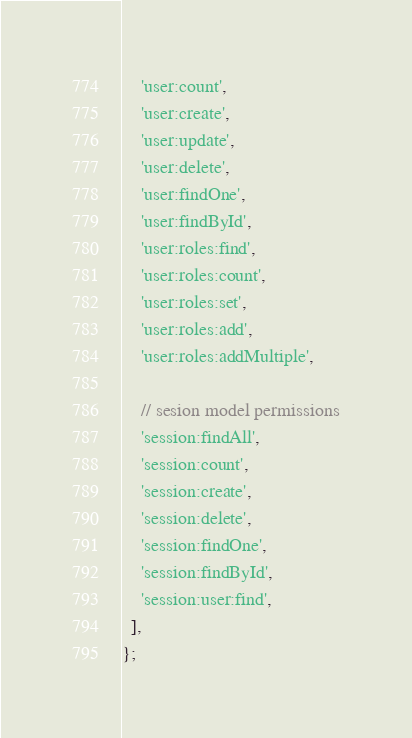<code> <loc_0><loc_0><loc_500><loc_500><_JavaScript_>    'user:count',
    'user:create',
    'user:update',
    'user:delete',
    'user:findOne',
    'user:findById',
    'user:roles:find',
    'user:roles:count',
    'user:roles:set',
    'user:roles:add',
    'user:roles:addMultiple',

    // sesion model permissions
    'session:findAll',
    'session:count',
    'session:create',
    'session:delete',
    'session:findOne',
    'session:findById',
    'session:user:find',
  ],
};
</code> 